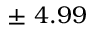<formula> <loc_0><loc_0><loc_500><loc_500>\pm \ 4 . 9 9 \</formula> 